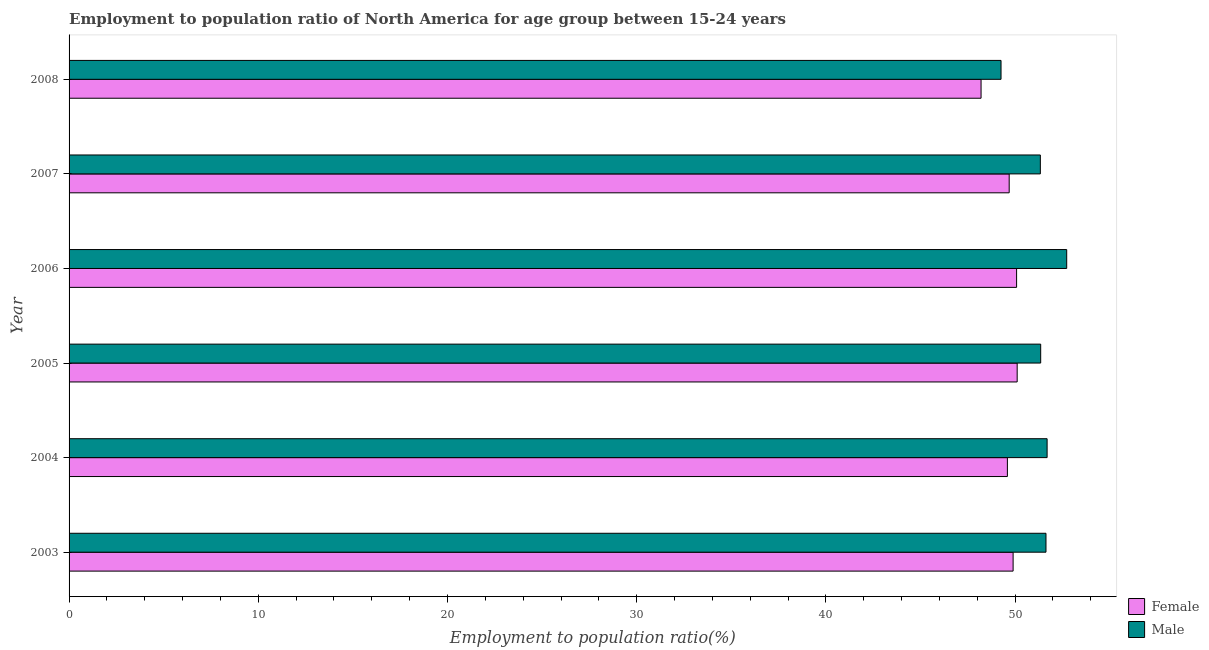Are the number of bars per tick equal to the number of legend labels?
Your answer should be compact. Yes. What is the employment to population ratio(male) in 2003?
Ensure brevity in your answer.  51.63. Across all years, what is the maximum employment to population ratio(male)?
Offer a very short reply. 52.73. Across all years, what is the minimum employment to population ratio(female)?
Your response must be concise. 48.2. What is the total employment to population ratio(male) in the graph?
Make the answer very short. 308. What is the difference between the employment to population ratio(male) in 2004 and that in 2008?
Your answer should be compact. 2.44. What is the difference between the employment to population ratio(female) in 2005 and the employment to population ratio(male) in 2007?
Provide a succinct answer. -1.22. What is the average employment to population ratio(female) per year?
Ensure brevity in your answer.  49.59. In the year 2005, what is the difference between the employment to population ratio(male) and employment to population ratio(female)?
Your answer should be compact. 1.24. In how many years, is the employment to population ratio(female) greater than 42 %?
Provide a short and direct response. 6. What is the ratio of the employment to population ratio(female) in 2007 to that in 2008?
Keep it short and to the point. 1.03. Is the employment to population ratio(female) in 2003 less than that in 2007?
Your answer should be very brief. No. Is the difference between the employment to population ratio(male) in 2003 and 2005 greater than the difference between the employment to population ratio(female) in 2003 and 2005?
Provide a succinct answer. Yes. What is the difference between the highest and the second highest employment to population ratio(male)?
Your response must be concise. 1.03. What is the difference between the highest and the lowest employment to population ratio(female)?
Your response must be concise. 1.91. In how many years, is the employment to population ratio(female) greater than the average employment to population ratio(female) taken over all years?
Offer a terse response. 4. Is the sum of the employment to population ratio(female) in 2003 and 2008 greater than the maximum employment to population ratio(male) across all years?
Your response must be concise. Yes. How many bars are there?
Provide a short and direct response. 12. Are the values on the major ticks of X-axis written in scientific E-notation?
Provide a succinct answer. No. Does the graph contain any zero values?
Provide a succinct answer. No. How many legend labels are there?
Ensure brevity in your answer.  2. What is the title of the graph?
Give a very brief answer. Employment to population ratio of North America for age group between 15-24 years. Does "Primary income" appear as one of the legend labels in the graph?
Give a very brief answer. No. What is the label or title of the X-axis?
Provide a short and direct response. Employment to population ratio(%). What is the label or title of the Y-axis?
Offer a very short reply. Year. What is the Employment to population ratio(%) of Female in 2003?
Give a very brief answer. 49.9. What is the Employment to population ratio(%) of Male in 2003?
Ensure brevity in your answer.  51.63. What is the Employment to population ratio(%) in Female in 2004?
Offer a very short reply. 49.59. What is the Employment to population ratio(%) in Male in 2004?
Offer a terse response. 51.69. What is the Employment to population ratio(%) of Female in 2005?
Offer a very short reply. 50.11. What is the Employment to population ratio(%) of Male in 2005?
Give a very brief answer. 51.35. What is the Employment to population ratio(%) of Female in 2006?
Offer a very short reply. 50.08. What is the Employment to population ratio(%) in Male in 2006?
Provide a succinct answer. 52.73. What is the Employment to population ratio(%) in Female in 2007?
Provide a succinct answer. 49.69. What is the Employment to population ratio(%) in Male in 2007?
Offer a terse response. 51.33. What is the Employment to population ratio(%) of Female in 2008?
Provide a short and direct response. 48.2. What is the Employment to population ratio(%) of Male in 2008?
Make the answer very short. 49.26. Across all years, what is the maximum Employment to population ratio(%) in Female?
Your answer should be compact. 50.11. Across all years, what is the maximum Employment to population ratio(%) of Male?
Ensure brevity in your answer.  52.73. Across all years, what is the minimum Employment to population ratio(%) of Female?
Offer a very short reply. 48.2. Across all years, what is the minimum Employment to population ratio(%) in Male?
Your answer should be very brief. 49.26. What is the total Employment to population ratio(%) of Female in the graph?
Your response must be concise. 297.57. What is the total Employment to population ratio(%) of Male in the graph?
Your answer should be compact. 308. What is the difference between the Employment to population ratio(%) in Female in 2003 and that in 2004?
Give a very brief answer. 0.3. What is the difference between the Employment to population ratio(%) of Male in 2003 and that in 2004?
Keep it short and to the point. -0.06. What is the difference between the Employment to population ratio(%) of Female in 2003 and that in 2005?
Provide a succinct answer. -0.21. What is the difference between the Employment to population ratio(%) in Male in 2003 and that in 2005?
Offer a very short reply. 0.28. What is the difference between the Employment to population ratio(%) of Female in 2003 and that in 2006?
Provide a short and direct response. -0.18. What is the difference between the Employment to population ratio(%) in Male in 2003 and that in 2006?
Give a very brief answer. -1.1. What is the difference between the Employment to population ratio(%) of Female in 2003 and that in 2007?
Provide a short and direct response. 0.21. What is the difference between the Employment to population ratio(%) in Male in 2003 and that in 2007?
Make the answer very short. 0.3. What is the difference between the Employment to population ratio(%) in Female in 2003 and that in 2008?
Provide a succinct answer. 1.69. What is the difference between the Employment to population ratio(%) in Male in 2003 and that in 2008?
Keep it short and to the point. 2.38. What is the difference between the Employment to population ratio(%) of Female in 2004 and that in 2005?
Offer a terse response. -0.52. What is the difference between the Employment to population ratio(%) of Male in 2004 and that in 2005?
Your answer should be very brief. 0.34. What is the difference between the Employment to population ratio(%) in Female in 2004 and that in 2006?
Offer a terse response. -0.49. What is the difference between the Employment to population ratio(%) in Male in 2004 and that in 2006?
Your answer should be compact. -1.04. What is the difference between the Employment to population ratio(%) in Female in 2004 and that in 2007?
Provide a short and direct response. -0.1. What is the difference between the Employment to population ratio(%) of Male in 2004 and that in 2007?
Keep it short and to the point. 0.36. What is the difference between the Employment to population ratio(%) in Female in 2004 and that in 2008?
Your response must be concise. 1.39. What is the difference between the Employment to population ratio(%) in Male in 2004 and that in 2008?
Provide a short and direct response. 2.44. What is the difference between the Employment to population ratio(%) in Female in 2005 and that in 2006?
Offer a terse response. 0.03. What is the difference between the Employment to population ratio(%) in Male in 2005 and that in 2006?
Provide a succinct answer. -1.38. What is the difference between the Employment to population ratio(%) in Female in 2005 and that in 2007?
Ensure brevity in your answer.  0.42. What is the difference between the Employment to population ratio(%) in Male in 2005 and that in 2007?
Provide a succinct answer. 0.02. What is the difference between the Employment to population ratio(%) of Female in 2005 and that in 2008?
Keep it short and to the point. 1.91. What is the difference between the Employment to population ratio(%) of Male in 2005 and that in 2008?
Your answer should be very brief. 2.1. What is the difference between the Employment to population ratio(%) of Female in 2006 and that in 2007?
Your response must be concise. 0.39. What is the difference between the Employment to population ratio(%) of Male in 2006 and that in 2007?
Your answer should be very brief. 1.39. What is the difference between the Employment to population ratio(%) of Female in 2006 and that in 2008?
Your answer should be very brief. 1.88. What is the difference between the Employment to population ratio(%) of Male in 2006 and that in 2008?
Provide a succinct answer. 3.47. What is the difference between the Employment to population ratio(%) in Female in 2007 and that in 2008?
Make the answer very short. 1.49. What is the difference between the Employment to population ratio(%) in Male in 2007 and that in 2008?
Offer a very short reply. 2.08. What is the difference between the Employment to population ratio(%) of Female in 2003 and the Employment to population ratio(%) of Male in 2004?
Ensure brevity in your answer.  -1.8. What is the difference between the Employment to population ratio(%) in Female in 2003 and the Employment to population ratio(%) in Male in 2005?
Your answer should be compact. -1.46. What is the difference between the Employment to population ratio(%) of Female in 2003 and the Employment to population ratio(%) of Male in 2006?
Your response must be concise. -2.83. What is the difference between the Employment to population ratio(%) in Female in 2003 and the Employment to population ratio(%) in Male in 2007?
Offer a very short reply. -1.44. What is the difference between the Employment to population ratio(%) of Female in 2003 and the Employment to population ratio(%) of Male in 2008?
Make the answer very short. 0.64. What is the difference between the Employment to population ratio(%) of Female in 2004 and the Employment to population ratio(%) of Male in 2005?
Offer a terse response. -1.76. What is the difference between the Employment to population ratio(%) in Female in 2004 and the Employment to population ratio(%) in Male in 2006?
Give a very brief answer. -3.13. What is the difference between the Employment to population ratio(%) of Female in 2004 and the Employment to population ratio(%) of Male in 2007?
Give a very brief answer. -1.74. What is the difference between the Employment to population ratio(%) of Female in 2004 and the Employment to population ratio(%) of Male in 2008?
Your response must be concise. 0.34. What is the difference between the Employment to population ratio(%) of Female in 2005 and the Employment to population ratio(%) of Male in 2006?
Give a very brief answer. -2.62. What is the difference between the Employment to population ratio(%) of Female in 2005 and the Employment to population ratio(%) of Male in 2007?
Keep it short and to the point. -1.22. What is the difference between the Employment to population ratio(%) of Female in 2005 and the Employment to population ratio(%) of Male in 2008?
Give a very brief answer. 0.85. What is the difference between the Employment to population ratio(%) of Female in 2006 and the Employment to population ratio(%) of Male in 2007?
Make the answer very short. -1.25. What is the difference between the Employment to population ratio(%) of Female in 2006 and the Employment to population ratio(%) of Male in 2008?
Offer a very short reply. 0.82. What is the difference between the Employment to population ratio(%) of Female in 2007 and the Employment to population ratio(%) of Male in 2008?
Your response must be concise. 0.43. What is the average Employment to population ratio(%) in Female per year?
Provide a succinct answer. 49.59. What is the average Employment to population ratio(%) of Male per year?
Your answer should be compact. 51.33. In the year 2003, what is the difference between the Employment to population ratio(%) in Female and Employment to population ratio(%) in Male?
Make the answer very short. -1.74. In the year 2004, what is the difference between the Employment to population ratio(%) in Female and Employment to population ratio(%) in Male?
Provide a short and direct response. -2.1. In the year 2005, what is the difference between the Employment to population ratio(%) of Female and Employment to population ratio(%) of Male?
Your response must be concise. -1.24. In the year 2006, what is the difference between the Employment to population ratio(%) in Female and Employment to population ratio(%) in Male?
Give a very brief answer. -2.65. In the year 2007, what is the difference between the Employment to population ratio(%) in Female and Employment to population ratio(%) in Male?
Keep it short and to the point. -1.65. In the year 2008, what is the difference between the Employment to population ratio(%) of Female and Employment to population ratio(%) of Male?
Your answer should be very brief. -1.06. What is the ratio of the Employment to population ratio(%) of Male in 2003 to that in 2004?
Offer a terse response. 1. What is the ratio of the Employment to population ratio(%) in Male in 2003 to that in 2005?
Provide a short and direct response. 1.01. What is the ratio of the Employment to population ratio(%) of Female in 2003 to that in 2006?
Offer a terse response. 1. What is the ratio of the Employment to population ratio(%) of Male in 2003 to that in 2006?
Provide a succinct answer. 0.98. What is the ratio of the Employment to population ratio(%) in Female in 2003 to that in 2007?
Offer a very short reply. 1. What is the ratio of the Employment to population ratio(%) of Male in 2003 to that in 2007?
Keep it short and to the point. 1.01. What is the ratio of the Employment to population ratio(%) of Female in 2003 to that in 2008?
Give a very brief answer. 1.04. What is the ratio of the Employment to population ratio(%) of Male in 2003 to that in 2008?
Keep it short and to the point. 1.05. What is the ratio of the Employment to population ratio(%) in Male in 2004 to that in 2005?
Offer a very short reply. 1.01. What is the ratio of the Employment to population ratio(%) of Female in 2004 to that in 2006?
Your answer should be very brief. 0.99. What is the ratio of the Employment to population ratio(%) in Male in 2004 to that in 2006?
Ensure brevity in your answer.  0.98. What is the ratio of the Employment to population ratio(%) of Female in 2004 to that in 2008?
Make the answer very short. 1.03. What is the ratio of the Employment to population ratio(%) of Male in 2004 to that in 2008?
Keep it short and to the point. 1.05. What is the ratio of the Employment to population ratio(%) of Female in 2005 to that in 2006?
Provide a short and direct response. 1. What is the ratio of the Employment to population ratio(%) in Male in 2005 to that in 2006?
Provide a succinct answer. 0.97. What is the ratio of the Employment to population ratio(%) in Female in 2005 to that in 2007?
Give a very brief answer. 1.01. What is the ratio of the Employment to population ratio(%) of Female in 2005 to that in 2008?
Your answer should be compact. 1.04. What is the ratio of the Employment to population ratio(%) in Male in 2005 to that in 2008?
Give a very brief answer. 1.04. What is the ratio of the Employment to population ratio(%) of Female in 2006 to that in 2007?
Offer a very short reply. 1.01. What is the ratio of the Employment to population ratio(%) of Male in 2006 to that in 2007?
Your answer should be compact. 1.03. What is the ratio of the Employment to population ratio(%) in Female in 2006 to that in 2008?
Your answer should be very brief. 1.04. What is the ratio of the Employment to population ratio(%) of Male in 2006 to that in 2008?
Provide a short and direct response. 1.07. What is the ratio of the Employment to population ratio(%) in Female in 2007 to that in 2008?
Make the answer very short. 1.03. What is the ratio of the Employment to population ratio(%) in Male in 2007 to that in 2008?
Your answer should be compact. 1.04. What is the difference between the highest and the second highest Employment to population ratio(%) in Female?
Your response must be concise. 0.03. What is the difference between the highest and the second highest Employment to population ratio(%) of Male?
Your answer should be compact. 1.04. What is the difference between the highest and the lowest Employment to population ratio(%) in Female?
Give a very brief answer. 1.91. What is the difference between the highest and the lowest Employment to population ratio(%) of Male?
Provide a succinct answer. 3.47. 